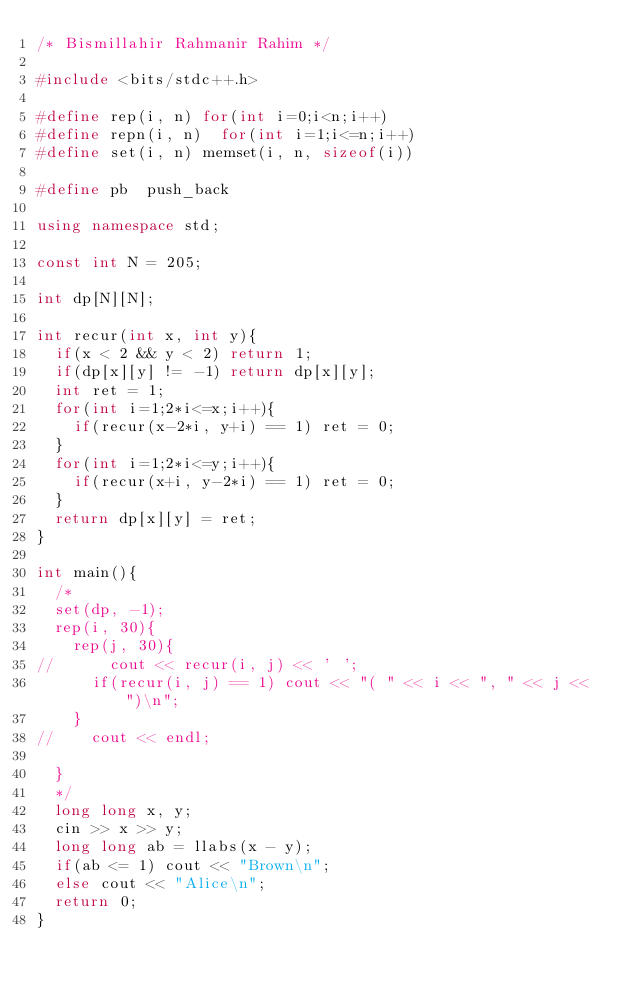Convert code to text. <code><loc_0><loc_0><loc_500><loc_500><_C++_>/* Bismillahir Rahmanir Rahim */

#include <bits/stdc++.h>

#define rep(i, n)	for(int i=0;i<n;i++)
#define repn(i, n)	for(int i=1;i<=n;i++)
#define set(i, n)	memset(i, n, sizeof(i))

#define pb	push_back

using namespace std;

const int N = 205;

int dp[N][N];

int recur(int x, int y){
	if(x < 2 && y < 2) return 1;
	if(dp[x][y] != -1) return dp[x][y];
	int ret = 1;
	for(int i=1;2*i<=x;i++){
		if(recur(x-2*i, y+i) == 1) ret = 0;
	}
	for(int i=1;2*i<=y;i++){
		if(recur(x+i, y-2*i) == 1) ret = 0;
	}
	return dp[x][y] = ret;
}

int main(){
	/*
	set(dp, -1);
	rep(i, 30){
		rep(j, 30){
//			cout << recur(i, j) << ' ';
			if(recur(i, j) == 1) cout << "( " << i << ", " << j << ")\n";
		}
//		cout << endl;

	}
	*/
	long long x, y;
	cin >> x >> y;
	long long ab = llabs(x - y);
	if(ab <= 1) cout << "Brown\n";
	else cout << "Alice\n";
	return 0;
}

</code> 